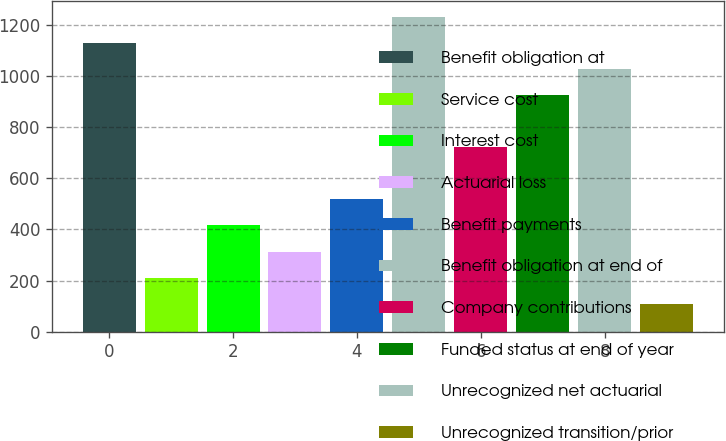Convert chart. <chart><loc_0><loc_0><loc_500><loc_500><bar_chart><fcel>Benefit obligation at<fcel>Service cost<fcel>Interest cost<fcel>Actuarial loss<fcel>Benefit payments<fcel>Benefit obligation at end of<fcel>Company contributions<fcel>Funded status at end of year<fcel>Unrecognized net actuarial<fcel>Unrecognized transition/prior<nl><fcel>1130.63<fcel>211.5<fcel>415.75<fcel>313.62<fcel>517.88<fcel>1232.76<fcel>722.12<fcel>926.38<fcel>1028.51<fcel>109.38<nl></chart> 